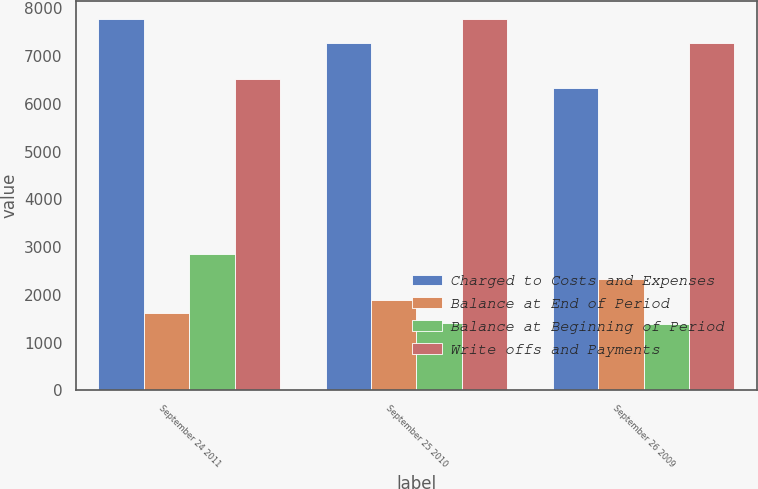Convert chart. <chart><loc_0><loc_0><loc_500><loc_500><stacked_bar_chart><ecel><fcel>September 24 2011<fcel>September 25 2010<fcel>September 26 2009<nl><fcel>Charged to Costs and Expenses<fcel>7769<fcel>7279<fcel>6326<nl><fcel>Balance at End of Period<fcel>1614<fcel>1895<fcel>2334<nl><fcel>Balance at Beginning of Period<fcel>2867<fcel>1405<fcel>1381<nl><fcel>Write offs and Payments<fcel>6516<fcel>7769<fcel>7279<nl></chart> 